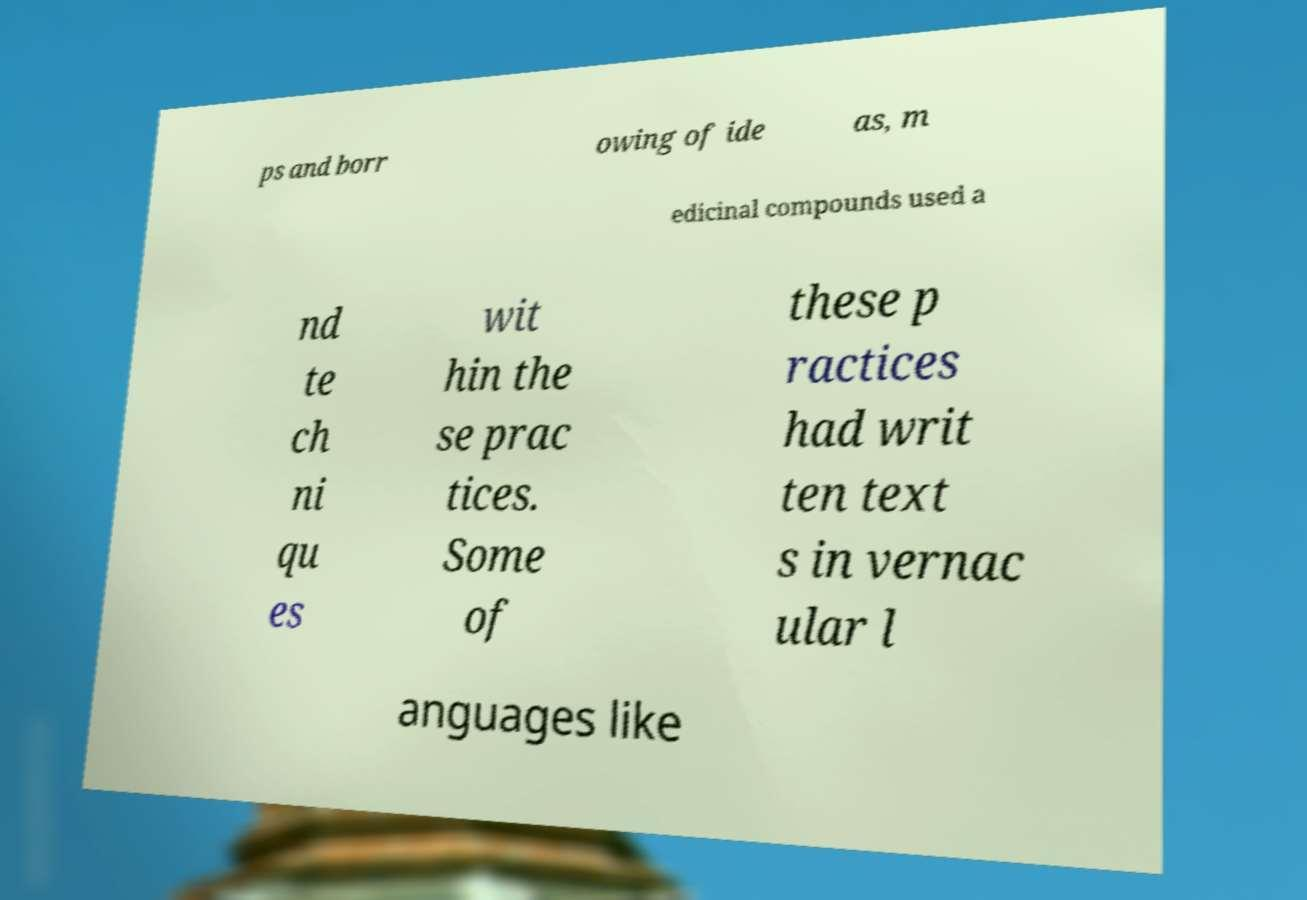Could you assist in decoding the text presented in this image and type it out clearly? ps and borr owing of ide as, m edicinal compounds used a nd te ch ni qu es wit hin the se prac tices. Some of these p ractices had writ ten text s in vernac ular l anguages like 